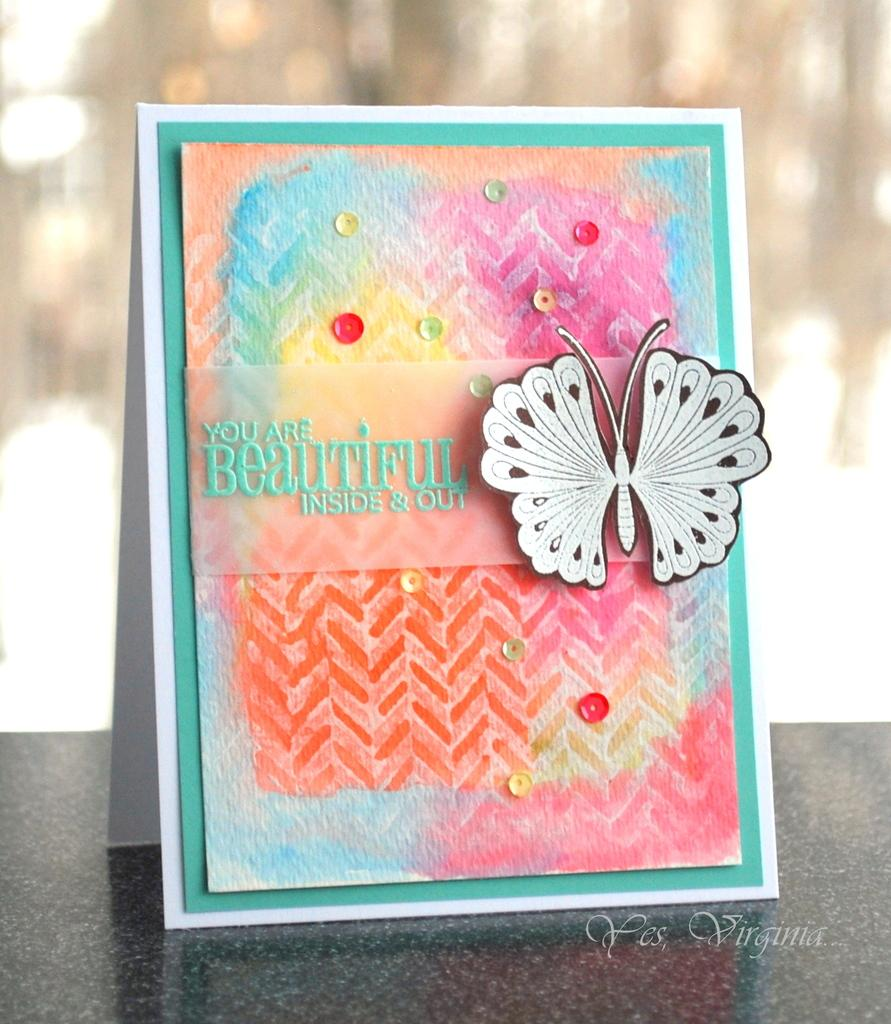What object is the main focus of the image? There is a greeting card in the image. Where is the greeting card placed? The greeting card is on a platform. What decorative element is on the greeting card? There is a butterfly sticker on the greeting card. What can be read on the greeting card? There is text written on the greeting card. How would you describe the background of the image? The background of the image is blurry. What type of secretary is visible in the image? There is no secretary present in the image; it features a greeting card on a platform with a butterfly sticker and text. How does the knot on the greeting card look like? There is no knot present on the greeting card in the image. 